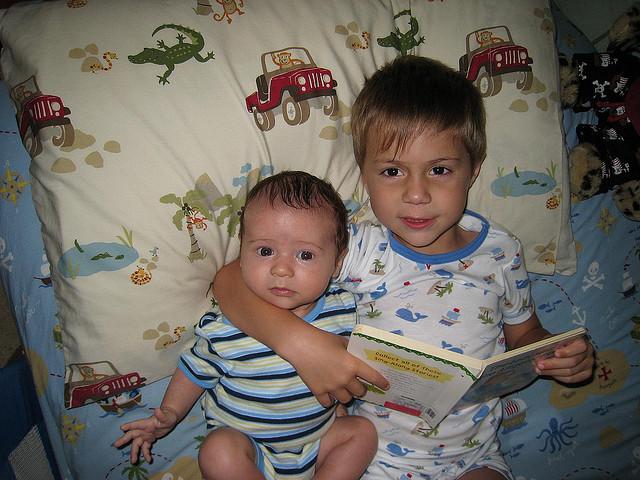What are the boys doing?
Quick response, please. Reading. What is the red object on the pillow case?
Answer briefly. Jeep. Is the bigger boy a brother?
Keep it brief. Yes. Is the baby happy?
Concise answer only. No. 